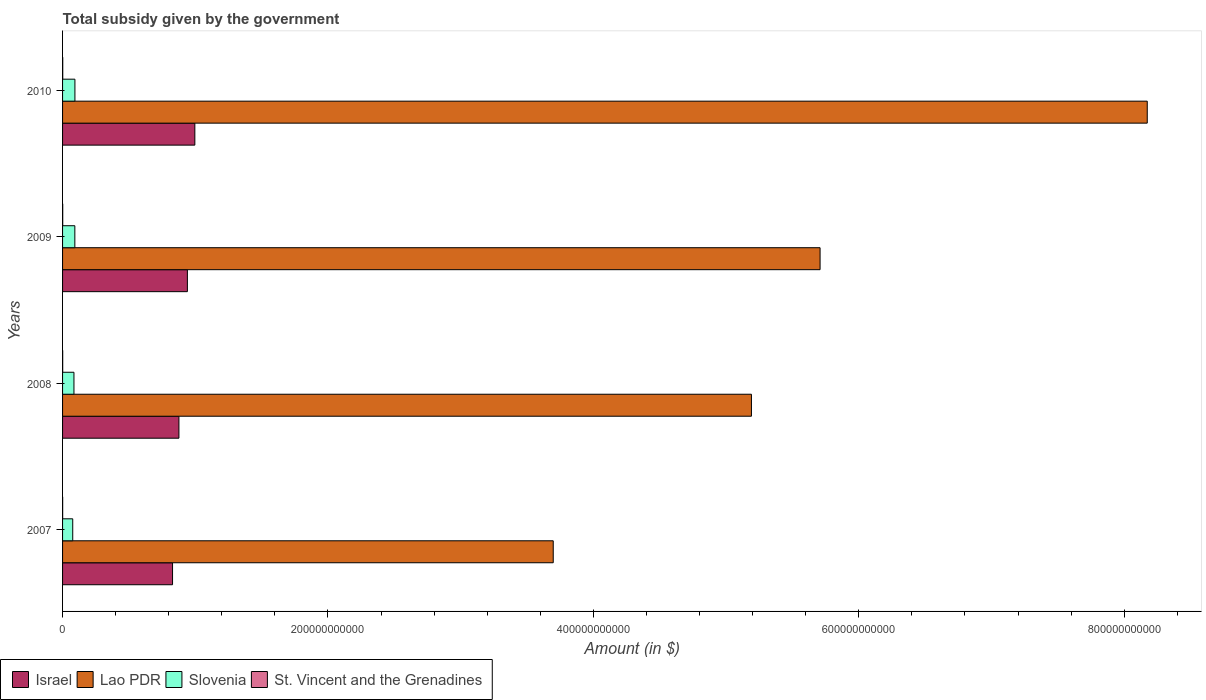Are the number of bars per tick equal to the number of legend labels?
Your answer should be compact. Yes. How many bars are there on the 2nd tick from the top?
Your answer should be compact. 4. In how many cases, is the number of bars for a given year not equal to the number of legend labels?
Offer a terse response. 0. What is the total revenue collected by the government in Lao PDR in 2010?
Give a very brief answer. 8.17e+11. Across all years, what is the maximum total revenue collected by the government in Lao PDR?
Your response must be concise. 8.17e+11. Across all years, what is the minimum total revenue collected by the government in St. Vincent and the Grenadines?
Offer a terse response. 6.99e+07. In which year was the total revenue collected by the government in Israel minimum?
Your response must be concise. 2007. What is the total total revenue collected by the government in Lao PDR in the graph?
Your response must be concise. 2.28e+12. What is the difference between the total revenue collected by the government in Lao PDR in 2007 and that in 2010?
Your response must be concise. -4.48e+11. What is the difference between the total revenue collected by the government in Slovenia in 2009 and the total revenue collected by the government in Israel in 2008?
Provide a succinct answer. -7.84e+1. What is the average total revenue collected by the government in St. Vincent and the Grenadines per year?
Your response must be concise. 1.02e+08. In the year 2007, what is the difference between the total revenue collected by the government in Israel and total revenue collected by the government in St. Vincent and the Grenadines?
Make the answer very short. 8.28e+1. What is the ratio of the total revenue collected by the government in St. Vincent and the Grenadines in 2007 to that in 2008?
Your answer should be very brief. 0.81. What is the difference between the highest and the second highest total revenue collected by the government in Slovenia?
Ensure brevity in your answer.  5.10e+07. What is the difference between the highest and the lowest total revenue collected by the government in Lao PDR?
Provide a succinct answer. 4.48e+11. What does the 1st bar from the top in 2007 represents?
Your answer should be very brief. St. Vincent and the Grenadines. What does the 2nd bar from the bottom in 2008 represents?
Provide a succinct answer. Lao PDR. What is the difference between two consecutive major ticks on the X-axis?
Keep it short and to the point. 2.00e+11. Does the graph contain any zero values?
Make the answer very short. No. Does the graph contain grids?
Your answer should be compact. No. Where does the legend appear in the graph?
Provide a succinct answer. Bottom left. How many legend labels are there?
Offer a terse response. 4. What is the title of the graph?
Your response must be concise. Total subsidy given by the government. Does "Sudan" appear as one of the legend labels in the graph?
Your response must be concise. No. What is the label or title of the X-axis?
Provide a succinct answer. Amount (in $). What is the Amount (in $) of Israel in 2007?
Provide a succinct answer. 8.29e+1. What is the Amount (in $) of Lao PDR in 2007?
Your answer should be very brief. 3.70e+11. What is the Amount (in $) in Slovenia in 2007?
Your answer should be compact. 7.66e+09. What is the Amount (in $) in St. Vincent and the Grenadines in 2007?
Make the answer very short. 6.99e+07. What is the Amount (in $) in Israel in 2008?
Offer a terse response. 8.77e+1. What is the Amount (in $) in Lao PDR in 2008?
Make the answer very short. 5.19e+11. What is the Amount (in $) of Slovenia in 2008?
Your answer should be compact. 8.58e+09. What is the Amount (in $) of St. Vincent and the Grenadines in 2008?
Offer a terse response. 8.62e+07. What is the Amount (in $) in Israel in 2009?
Make the answer very short. 9.41e+1. What is the Amount (in $) in Lao PDR in 2009?
Offer a terse response. 5.71e+11. What is the Amount (in $) in Slovenia in 2009?
Your answer should be compact. 9.25e+09. What is the Amount (in $) of St. Vincent and the Grenadines in 2009?
Keep it short and to the point. 1.21e+08. What is the Amount (in $) in Israel in 2010?
Ensure brevity in your answer.  9.97e+1. What is the Amount (in $) in Lao PDR in 2010?
Offer a very short reply. 8.17e+11. What is the Amount (in $) in Slovenia in 2010?
Make the answer very short. 9.31e+09. What is the Amount (in $) of St. Vincent and the Grenadines in 2010?
Your answer should be compact. 1.32e+08. Across all years, what is the maximum Amount (in $) in Israel?
Your answer should be compact. 9.97e+1. Across all years, what is the maximum Amount (in $) of Lao PDR?
Ensure brevity in your answer.  8.17e+11. Across all years, what is the maximum Amount (in $) of Slovenia?
Ensure brevity in your answer.  9.31e+09. Across all years, what is the maximum Amount (in $) of St. Vincent and the Grenadines?
Keep it short and to the point. 1.32e+08. Across all years, what is the minimum Amount (in $) of Israel?
Keep it short and to the point. 8.29e+1. Across all years, what is the minimum Amount (in $) of Lao PDR?
Your answer should be compact. 3.70e+11. Across all years, what is the minimum Amount (in $) in Slovenia?
Keep it short and to the point. 7.66e+09. Across all years, what is the minimum Amount (in $) of St. Vincent and the Grenadines?
Keep it short and to the point. 6.99e+07. What is the total Amount (in $) of Israel in the graph?
Ensure brevity in your answer.  3.64e+11. What is the total Amount (in $) of Lao PDR in the graph?
Your response must be concise. 2.28e+12. What is the total Amount (in $) of Slovenia in the graph?
Offer a terse response. 3.48e+1. What is the total Amount (in $) of St. Vincent and the Grenadines in the graph?
Your response must be concise. 4.09e+08. What is the difference between the Amount (in $) in Israel in 2007 and that in 2008?
Give a very brief answer. -4.80e+09. What is the difference between the Amount (in $) in Lao PDR in 2007 and that in 2008?
Your response must be concise. -1.49e+11. What is the difference between the Amount (in $) in Slovenia in 2007 and that in 2008?
Make the answer very short. -9.21e+08. What is the difference between the Amount (in $) in St. Vincent and the Grenadines in 2007 and that in 2008?
Your answer should be very brief. -1.63e+07. What is the difference between the Amount (in $) in Israel in 2007 and that in 2009?
Offer a very short reply. -1.12e+1. What is the difference between the Amount (in $) of Lao PDR in 2007 and that in 2009?
Make the answer very short. -2.01e+11. What is the difference between the Amount (in $) of Slovenia in 2007 and that in 2009?
Make the answer very short. -1.60e+09. What is the difference between the Amount (in $) in St. Vincent and the Grenadines in 2007 and that in 2009?
Keep it short and to the point. -5.08e+07. What is the difference between the Amount (in $) in Israel in 2007 and that in 2010?
Keep it short and to the point. -1.68e+1. What is the difference between the Amount (in $) of Lao PDR in 2007 and that in 2010?
Ensure brevity in your answer.  -4.48e+11. What is the difference between the Amount (in $) in Slovenia in 2007 and that in 2010?
Provide a short and direct response. -1.65e+09. What is the difference between the Amount (in $) in St. Vincent and the Grenadines in 2007 and that in 2010?
Give a very brief answer. -6.20e+07. What is the difference between the Amount (in $) of Israel in 2008 and that in 2009?
Make the answer very short. -6.38e+09. What is the difference between the Amount (in $) in Lao PDR in 2008 and that in 2009?
Your response must be concise. -5.17e+1. What is the difference between the Amount (in $) of Slovenia in 2008 and that in 2009?
Ensure brevity in your answer.  -6.75e+08. What is the difference between the Amount (in $) in St. Vincent and the Grenadines in 2008 and that in 2009?
Your answer should be compact. -3.45e+07. What is the difference between the Amount (in $) of Israel in 2008 and that in 2010?
Keep it short and to the point. -1.20e+1. What is the difference between the Amount (in $) in Lao PDR in 2008 and that in 2010?
Your answer should be compact. -2.98e+11. What is the difference between the Amount (in $) of Slovenia in 2008 and that in 2010?
Keep it short and to the point. -7.26e+08. What is the difference between the Amount (in $) of St. Vincent and the Grenadines in 2008 and that in 2010?
Your response must be concise. -4.57e+07. What is the difference between the Amount (in $) of Israel in 2009 and that in 2010?
Make the answer very short. -5.62e+09. What is the difference between the Amount (in $) in Lao PDR in 2009 and that in 2010?
Your answer should be compact. -2.47e+11. What is the difference between the Amount (in $) in Slovenia in 2009 and that in 2010?
Provide a short and direct response. -5.10e+07. What is the difference between the Amount (in $) of St. Vincent and the Grenadines in 2009 and that in 2010?
Ensure brevity in your answer.  -1.12e+07. What is the difference between the Amount (in $) of Israel in 2007 and the Amount (in $) of Lao PDR in 2008?
Ensure brevity in your answer.  -4.36e+11. What is the difference between the Amount (in $) of Israel in 2007 and the Amount (in $) of Slovenia in 2008?
Offer a terse response. 7.43e+1. What is the difference between the Amount (in $) of Israel in 2007 and the Amount (in $) of St. Vincent and the Grenadines in 2008?
Provide a succinct answer. 8.28e+1. What is the difference between the Amount (in $) of Lao PDR in 2007 and the Amount (in $) of Slovenia in 2008?
Keep it short and to the point. 3.61e+11. What is the difference between the Amount (in $) of Lao PDR in 2007 and the Amount (in $) of St. Vincent and the Grenadines in 2008?
Ensure brevity in your answer.  3.70e+11. What is the difference between the Amount (in $) in Slovenia in 2007 and the Amount (in $) in St. Vincent and the Grenadines in 2008?
Ensure brevity in your answer.  7.57e+09. What is the difference between the Amount (in $) in Israel in 2007 and the Amount (in $) in Lao PDR in 2009?
Offer a very short reply. -4.88e+11. What is the difference between the Amount (in $) in Israel in 2007 and the Amount (in $) in Slovenia in 2009?
Keep it short and to the point. 7.36e+1. What is the difference between the Amount (in $) of Israel in 2007 and the Amount (in $) of St. Vincent and the Grenadines in 2009?
Provide a short and direct response. 8.28e+1. What is the difference between the Amount (in $) of Lao PDR in 2007 and the Amount (in $) of Slovenia in 2009?
Offer a terse response. 3.60e+11. What is the difference between the Amount (in $) in Lao PDR in 2007 and the Amount (in $) in St. Vincent and the Grenadines in 2009?
Ensure brevity in your answer.  3.70e+11. What is the difference between the Amount (in $) of Slovenia in 2007 and the Amount (in $) of St. Vincent and the Grenadines in 2009?
Your answer should be very brief. 7.54e+09. What is the difference between the Amount (in $) of Israel in 2007 and the Amount (in $) of Lao PDR in 2010?
Offer a terse response. -7.34e+11. What is the difference between the Amount (in $) in Israel in 2007 and the Amount (in $) in Slovenia in 2010?
Ensure brevity in your answer.  7.36e+1. What is the difference between the Amount (in $) of Israel in 2007 and the Amount (in $) of St. Vincent and the Grenadines in 2010?
Keep it short and to the point. 8.27e+1. What is the difference between the Amount (in $) of Lao PDR in 2007 and the Amount (in $) of Slovenia in 2010?
Keep it short and to the point. 3.60e+11. What is the difference between the Amount (in $) in Lao PDR in 2007 and the Amount (in $) in St. Vincent and the Grenadines in 2010?
Offer a very short reply. 3.70e+11. What is the difference between the Amount (in $) of Slovenia in 2007 and the Amount (in $) of St. Vincent and the Grenadines in 2010?
Provide a succinct answer. 7.53e+09. What is the difference between the Amount (in $) in Israel in 2008 and the Amount (in $) in Lao PDR in 2009?
Offer a very short reply. -4.83e+11. What is the difference between the Amount (in $) in Israel in 2008 and the Amount (in $) in Slovenia in 2009?
Keep it short and to the point. 7.84e+1. What is the difference between the Amount (in $) of Israel in 2008 and the Amount (in $) of St. Vincent and the Grenadines in 2009?
Provide a succinct answer. 8.76e+1. What is the difference between the Amount (in $) in Lao PDR in 2008 and the Amount (in $) in Slovenia in 2009?
Provide a succinct answer. 5.10e+11. What is the difference between the Amount (in $) of Lao PDR in 2008 and the Amount (in $) of St. Vincent and the Grenadines in 2009?
Your answer should be very brief. 5.19e+11. What is the difference between the Amount (in $) of Slovenia in 2008 and the Amount (in $) of St. Vincent and the Grenadines in 2009?
Provide a short and direct response. 8.46e+09. What is the difference between the Amount (in $) in Israel in 2008 and the Amount (in $) in Lao PDR in 2010?
Provide a short and direct response. -7.30e+11. What is the difference between the Amount (in $) in Israel in 2008 and the Amount (in $) in Slovenia in 2010?
Offer a very short reply. 7.84e+1. What is the difference between the Amount (in $) in Israel in 2008 and the Amount (in $) in St. Vincent and the Grenadines in 2010?
Your response must be concise. 8.75e+1. What is the difference between the Amount (in $) in Lao PDR in 2008 and the Amount (in $) in Slovenia in 2010?
Offer a very short reply. 5.10e+11. What is the difference between the Amount (in $) of Lao PDR in 2008 and the Amount (in $) of St. Vincent and the Grenadines in 2010?
Provide a succinct answer. 5.19e+11. What is the difference between the Amount (in $) of Slovenia in 2008 and the Amount (in $) of St. Vincent and the Grenadines in 2010?
Give a very brief answer. 8.45e+09. What is the difference between the Amount (in $) of Israel in 2009 and the Amount (in $) of Lao PDR in 2010?
Provide a short and direct response. -7.23e+11. What is the difference between the Amount (in $) in Israel in 2009 and the Amount (in $) in Slovenia in 2010?
Provide a short and direct response. 8.48e+1. What is the difference between the Amount (in $) in Israel in 2009 and the Amount (in $) in St. Vincent and the Grenadines in 2010?
Offer a terse response. 9.39e+1. What is the difference between the Amount (in $) of Lao PDR in 2009 and the Amount (in $) of Slovenia in 2010?
Keep it short and to the point. 5.62e+11. What is the difference between the Amount (in $) in Lao PDR in 2009 and the Amount (in $) in St. Vincent and the Grenadines in 2010?
Your response must be concise. 5.71e+11. What is the difference between the Amount (in $) in Slovenia in 2009 and the Amount (in $) in St. Vincent and the Grenadines in 2010?
Your response must be concise. 9.12e+09. What is the average Amount (in $) in Israel per year?
Make the answer very short. 9.11e+1. What is the average Amount (in $) of Lao PDR per year?
Give a very brief answer. 5.69e+11. What is the average Amount (in $) in Slovenia per year?
Your response must be concise. 8.70e+09. What is the average Amount (in $) of St. Vincent and the Grenadines per year?
Keep it short and to the point. 1.02e+08. In the year 2007, what is the difference between the Amount (in $) in Israel and Amount (in $) in Lao PDR?
Give a very brief answer. -2.87e+11. In the year 2007, what is the difference between the Amount (in $) in Israel and Amount (in $) in Slovenia?
Give a very brief answer. 7.52e+1. In the year 2007, what is the difference between the Amount (in $) in Israel and Amount (in $) in St. Vincent and the Grenadines?
Provide a succinct answer. 8.28e+1. In the year 2007, what is the difference between the Amount (in $) of Lao PDR and Amount (in $) of Slovenia?
Provide a succinct answer. 3.62e+11. In the year 2007, what is the difference between the Amount (in $) in Lao PDR and Amount (in $) in St. Vincent and the Grenadines?
Ensure brevity in your answer.  3.70e+11. In the year 2007, what is the difference between the Amount (in $) of Slovenia and Amount (in $) of St. Vincent and the Grenadines?
Keep it short and to the point. 7.59e+09. In the year 2008, what is the difference between the Amount (in $) in Israel and Amount (in $) in Lao PDR?
Keep it short and to the point. -4.31e+11. In the year 2008, what is the difference between the Amount (in $) in Israel and Amount (in $) in Slovenia?
Make the answer very short. 7.91e+1. In the year 2008, what is the difference between the Amount (in $) of Israel and Amount (in $) of St. Vincent and the Grenadines?
Provide a short and direct response. 8.76e+1. In the year 2008, what is the difference between the Amount (in $) in Lao PDR and Amount (in $) in Slovenia?
Keep it short and to the point. 5.11e+11. In the year 2008, what is the difference between the Amount (in $) in Lao PDR and Amount (in $) in St. Vincent and the Grenadines?
Provide a succinct answer. 5.19e+11. In the year 2008, what is the difference between the Amount (in $) in Slovenia and Amount (in $) in St. Vincent and the Grenadines?
Give a very brief answer. 8.49e+09. In the year 2009, what is the difference between the Amount (in $) of Israel and Amount (in $) of Lao PDR?
Your answer should be compact. -4.77e+11. In the year 2009, what is the difference between the Amount (in $) in Israel and Amount (in $) in Slovenia?
Your response must be concise. 8.48e+1. In the year 2009, what is the difference between the Amount (in $) in Israel and Amount (in $) in St. Vincent and the Grenadines?
Provide a short and direct response. 9.39e+1. In the year 2009, what is the difference between the Amount (in $) of Lao PDR and Amount (in $) of Slovenia?
Offer a terse response. 5.62e+11. In the year 2009, what is the difference between the Amount (in $) of Lao PDR and Amount (in $) of St. Vincent and the Grenadines?
Your response must be concise. 5.71e+11. In the year 2009, what is the difference between the Amount (in $) in Slovenia and Amount (in $) in St. Vincent and the Grenadines?
Give a very brief answer. 9.13e+09. In the year 2010, what is the difference between the Amount (in $) in Israel and Amount (in $) in Lao PDR?
Your answer should be very brief. -7.18e+11. In the year 2010, what is the difference between the Amount (in $) in Israel and Amount (in $) in Slovenia?
Your answer should be very brief. 9.04e+1. In the year 2010, what is the difference between the Amount (in $) in Israel and Amount (in $) in St. Vincent and the Grenadines?
Offer a very short reply. 9.95e+1. In the year 2010, what is the difference between the Amount (in $) of Lao PDR and Amount (in $) of Slovenia?
Keep it short and to the point. 8.08e+11. In the year 2010, what is the difference between the Amount (in $) of Lao PDR and Amount (in $) of St. Vincent and the Grenadines?
Give a very brief answer. 8.17e+11. In the year 2010, what is the difference between the Amount (in $) in Slovenia and Amount (in $) in St. Vincent and the Grenadines?
Give a very brief answer. 9.17e+09. What is the ratio of the Amount (in $) of Israel in 2007 to that in 2008?
Ensure brevity in your answer.  0.95. What is the ratio of the Amount (in $) in Lao PDR in 2007 to that in 2008?
Your answer should be very brief. 0.71. What is the ratio of the Amount (in $) of Slovenia in 2007 to that in 2008?
Ensure brevity in your answer.  0.89. What is the ratio of the Amount (in $) of St. Vincent and the Grenadines in 2007 to that in 2008?
Make the answer very short. 0.81. What is the ratio of the Amount (in $) of Israel in 2007 to that in 2009?
Give a very brief answer. 0.88. What is the ratio of the Amount (in $) in Lao PDR in 2007 to that in 2009?
Ensure brevity in your answer.  0.65. What is the ratio of the Amount (in $) of Slovenia in 2007 to that in 2009?
Offer a very short reply. 0.83. What is the ratio of the Amount (in $) of St. Vincent and the Grenadines in 2007 to that in 2009?
Provide a short and direct response. 0.58. What is the ratio of the Amount (in $) of Israel in 2007 to that in 2010?
Provide a succinct answer. 0.83. What is the ratio of the Amount (in $) in Lao PDR in 2007 to that in 2010?
Offer a very short reply. 0.45. What is the ratio of the Amount (in $) in Slovenia in 2007 to that in 2010?
Your answer should be very brief. 0.82. What is the ratio of the Amount (in $) in St. Vincent and the Grenadines in 2007 to that in 2010?
Give a very brief answer. 0.53. What is the ratio of the Amount (in $) in Israel in 2008 to that in 2009?
Provide a short and direct response. 0.93. What is the ratio of the Amount (in $) in Lao PDR in 2008 to that in 2009?
Provide a short and direct response. 0.91. What is the ratio of the Amount (in $) in Slovenia in 2008 to that in 2009?
Ensure brevity in your answer.  0.93. What is the ratio of the Amount (in $) of St. Vincent and the Grenadines in 2008 to that in 2009?
Provide a succinct answer. 0.71. What is the ratio of the Amount (in $) of Israel in 2008 to that in 2010?
Provide a succinct answer. 0.88. What is the ratio of the Amount (in $) in Lao PDR in 2008 to that in 2010?
Keep it short and to the point. 0.64. What is the ratio of the Amount (in $) of Slovenia in 2008 to that in 2010?
Offer a terse response. 0.92. What is the ratio of the Amount (in $) in St. Vincent and the Grenadines in 2008 to that in 2010?
Give a very brief answer. 0.65. What is the ratio of the Amount (in $) of Israel in 2009 to that in 2010?
Your answer should be very brief. 0.94. What is the ratio of the Amount (in $) of Lao PDR in 2009 to that in 2010?
Provide a short and direct response. 0.7. What is the ratio of the Amount (in $) of Slovenia in 2009 to that in 2010?
Offer a terse response. 0.99. What is the ratio of the Amount (in $) of St. Vincent and the Grenadines in 2009 to that in 2010?
Your answer should be very brief. 0.92. What is the difference between the highest and the second highest Amount (in $) in Israel?
Ensure brevity in your answer.  5.62e+09. What is the difference between the highest and the second highest Amount (in $) in Lao PDR?
Your response must be concise. 2.47e+11. What is the difference between the highest and the second highest Amount (in $) in Slovenia?
Provide a succinct answer. 5.10e+07. What is the difference between the highest and the second highest Amount (in $) of St. Vincent and the Grenadines?
Keep it short and to the point. 1.12e+07. What is the difference between the highest and the lowest Amount (in $) of Israel?
Your response must be concise. 1.68e+1. What is the difference between the highest and the lowest Amount (in $) of Lao PDR?
Give a very brief answer. 4.48e+11. What is the difference between the highest and the lowest Amount (in $) in Slovenia?
Offer a terse response. 1.65e+09. What is the difference between the highest and the lowest Amount (in $) in St. Vincent and the Grenadines?
Make the answer very short. 6.20e+07. 